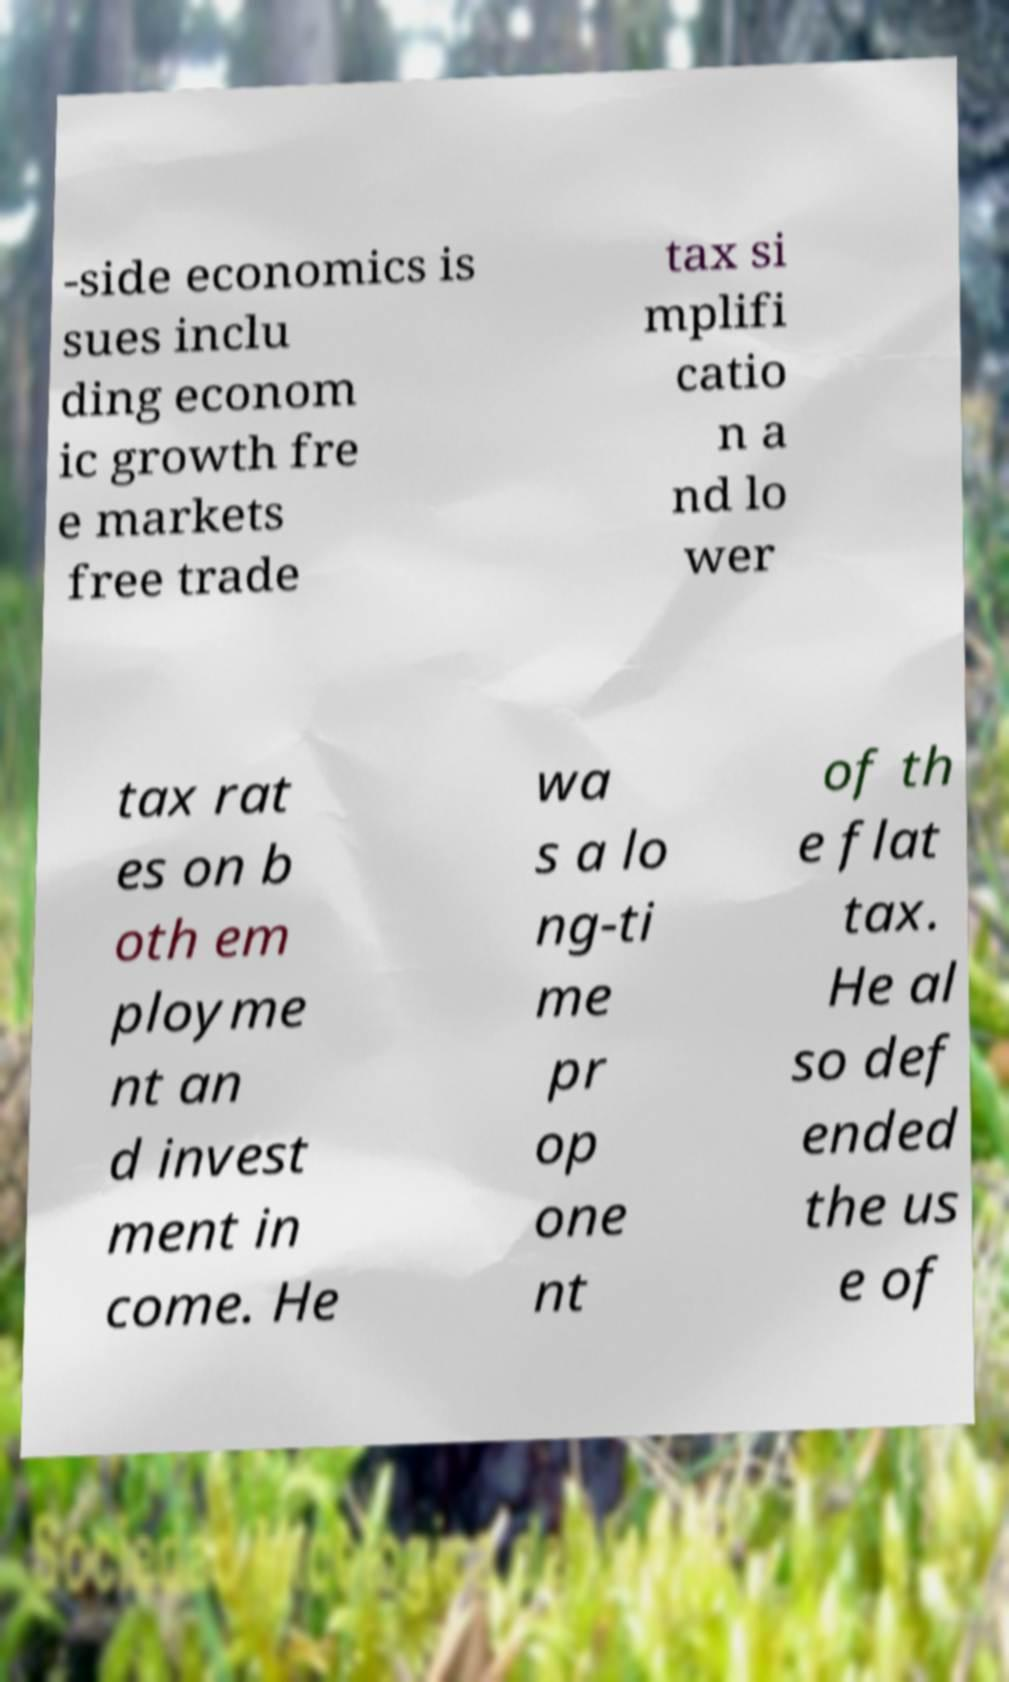Could you extract and type out the text from this image? -side economics is sues inclu ding econom ic growth fre e markets free trade tax si mplifi catio n a nd lo wer tax rat es on b oth em ployme nt an d invest ment in come. He wa s a lo ng-ti me pr op one nt of th e flat tax. He al so def ended the us e of 